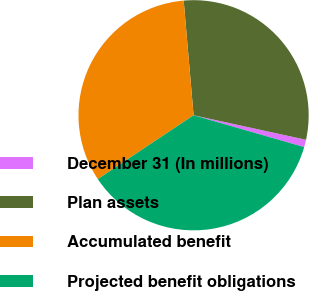<chart> <loc_0><loc_0><loc_500><loc_500><pie_chart><fcel>December 31 (In millions)<fcel>Plan assets<fcel>Accumulated benefit<fcel>Projected benefit obligations<nl><fcel>1.04%<fcel>29.79%<fcel>32.99%<fcel>36.18%<nl></chart> 